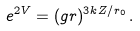Convert formula to latex. <formula><loc_0><loc_0><loc_500><loc_500>e ^ { 2 V } = ( g r ) ^ { 3 k Z / r _ { 0 } } \, .</formula> 